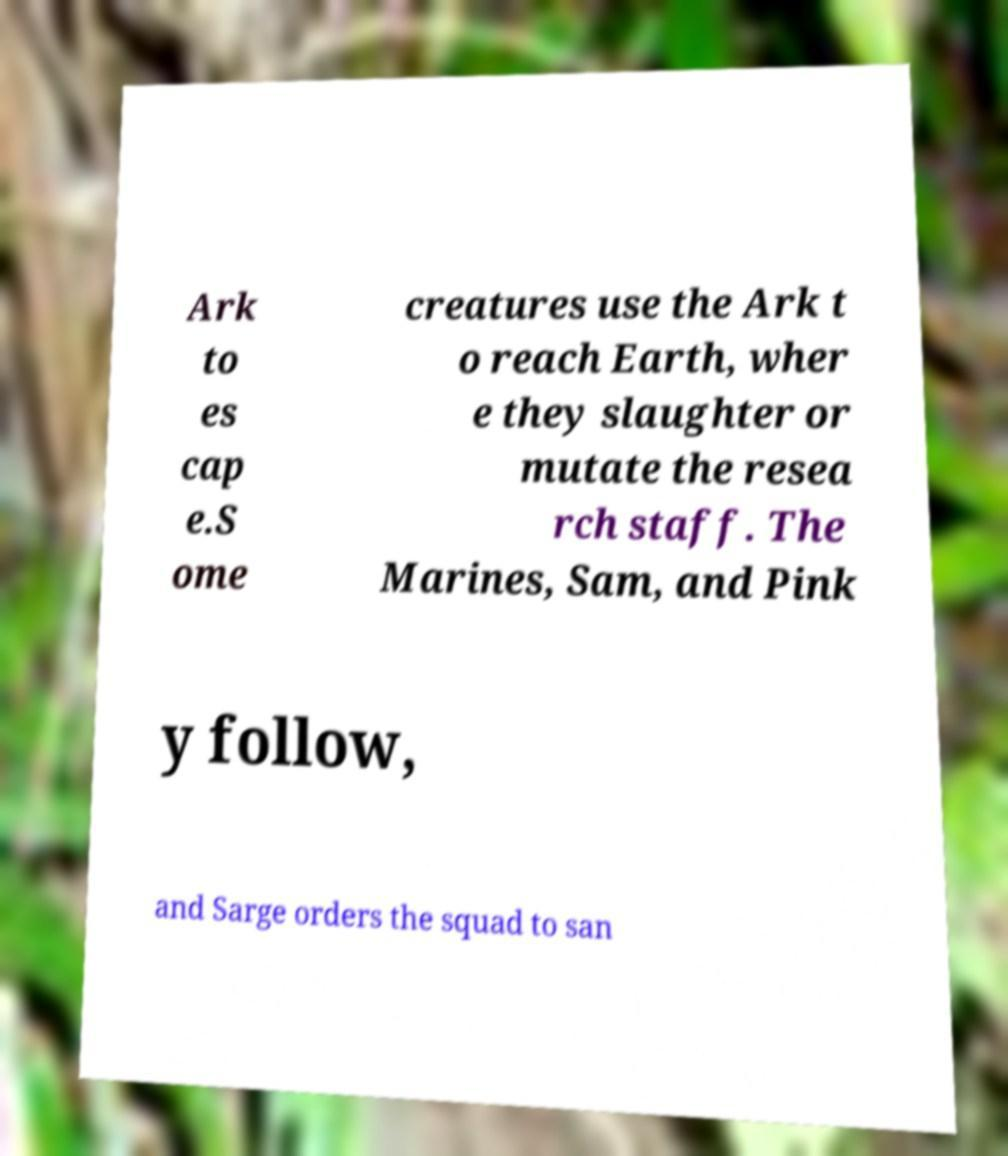Could you extract and type out the text from this image? Ark to es cap e.S ome creatures use the Ark t o reach Earth, wher e they slaughter or mutate the resea rch staff. The Marines, Sam, and Pink y follow, and Sarge orders the squad to san 